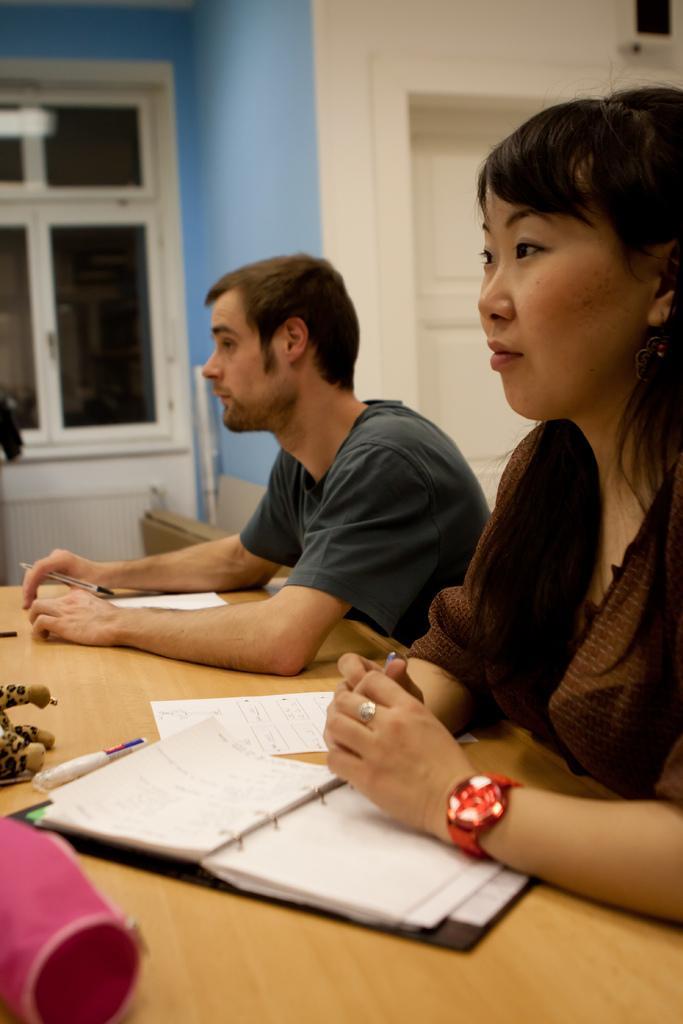Could you give a brief overview of what you see in this image? In the foreground of this image, there is a woman and a man sitting in front of a table on which there is a pouch, marker and papers and they are holding pens. In the background, there is a window and a wall. 